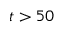Convert formula to latex. <formula><loc_0><loc_0><loc_500><loc_500>t > 5 0</formula> 